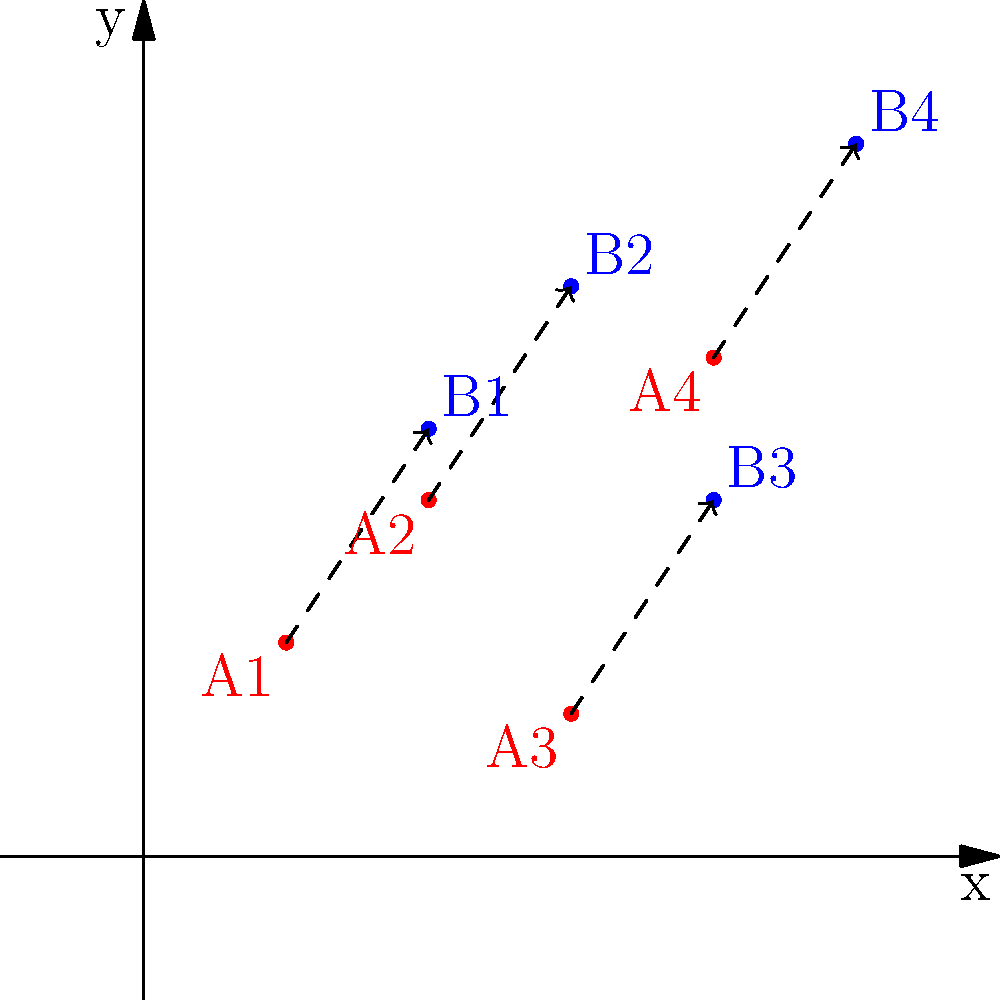In a study on migration patterns, demographic data points were translated on a coordinate plane. The original points (in red) represent the initial locations of four population groups, while the translated points (in blue) represent their new locations after migration. Determine the translation vector that describes this migration pattern. To find the translation vector, we need to analyze how each point has moved from its original position to its new position. Let's follow these steps:

1. Identify the coordinates of each pair of points (original and translated):
   A1(2,3) → B1(4,6)
   A2(4,5) → B2(6,8)
   A3(6,2) → B3(8,5)
   A4(8,7) → B4(10,10)

2. Calculate the displacement for each pair:
   For A1 to B1: (4-2, 6-3) = (2,3)
   For A2 to B2: (6-4, 8-5) = (2,3)
   For A3 to B3: (8-6, 5-2) = (2,3)
   For A4 to B4: (10-8, 10-7) = (2,3)

3. Observe that the displacement is consistent for all pairs of points.

4. Express the translation as a vector:
   The translation vector is $\vec{v} = \langle 2, 3 \rangle$

This vector indicates that each point has been moved 2 units to the right and 3 units up, representing the general migration pattern of the population groups in this study.
Answer: $\vec{v} = \langle 2, 3 \rangle$ 